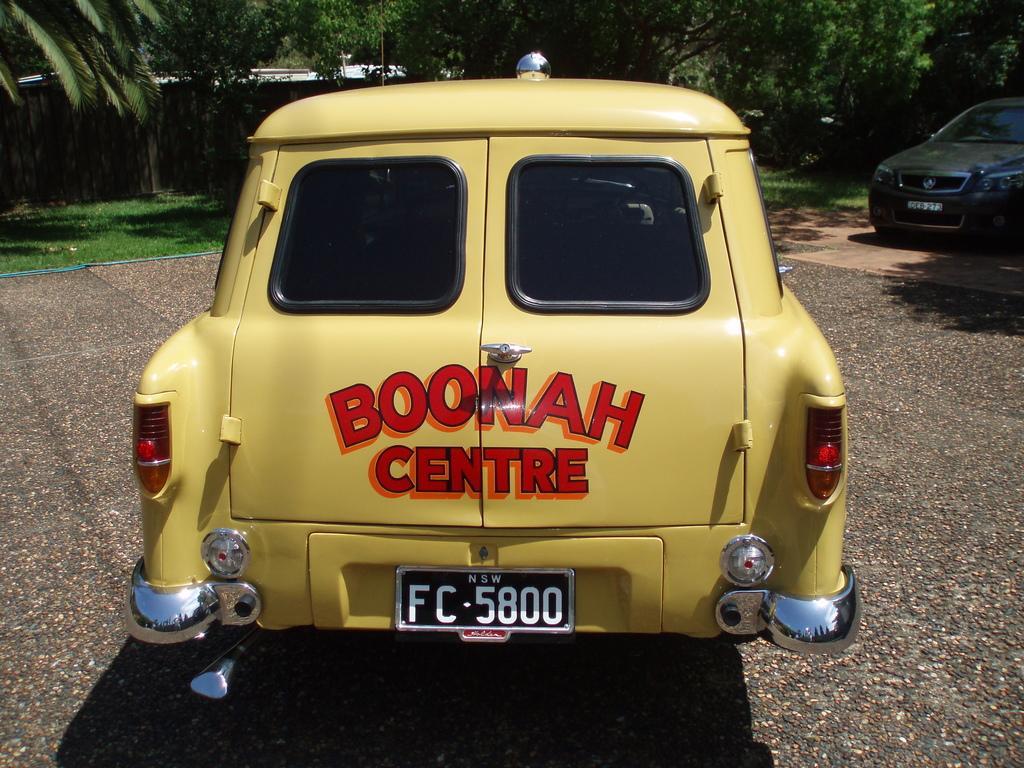How would you summarize this image in a sentence or two? In this image we can see there are cars on the ground and there are trees and grass at the back. 